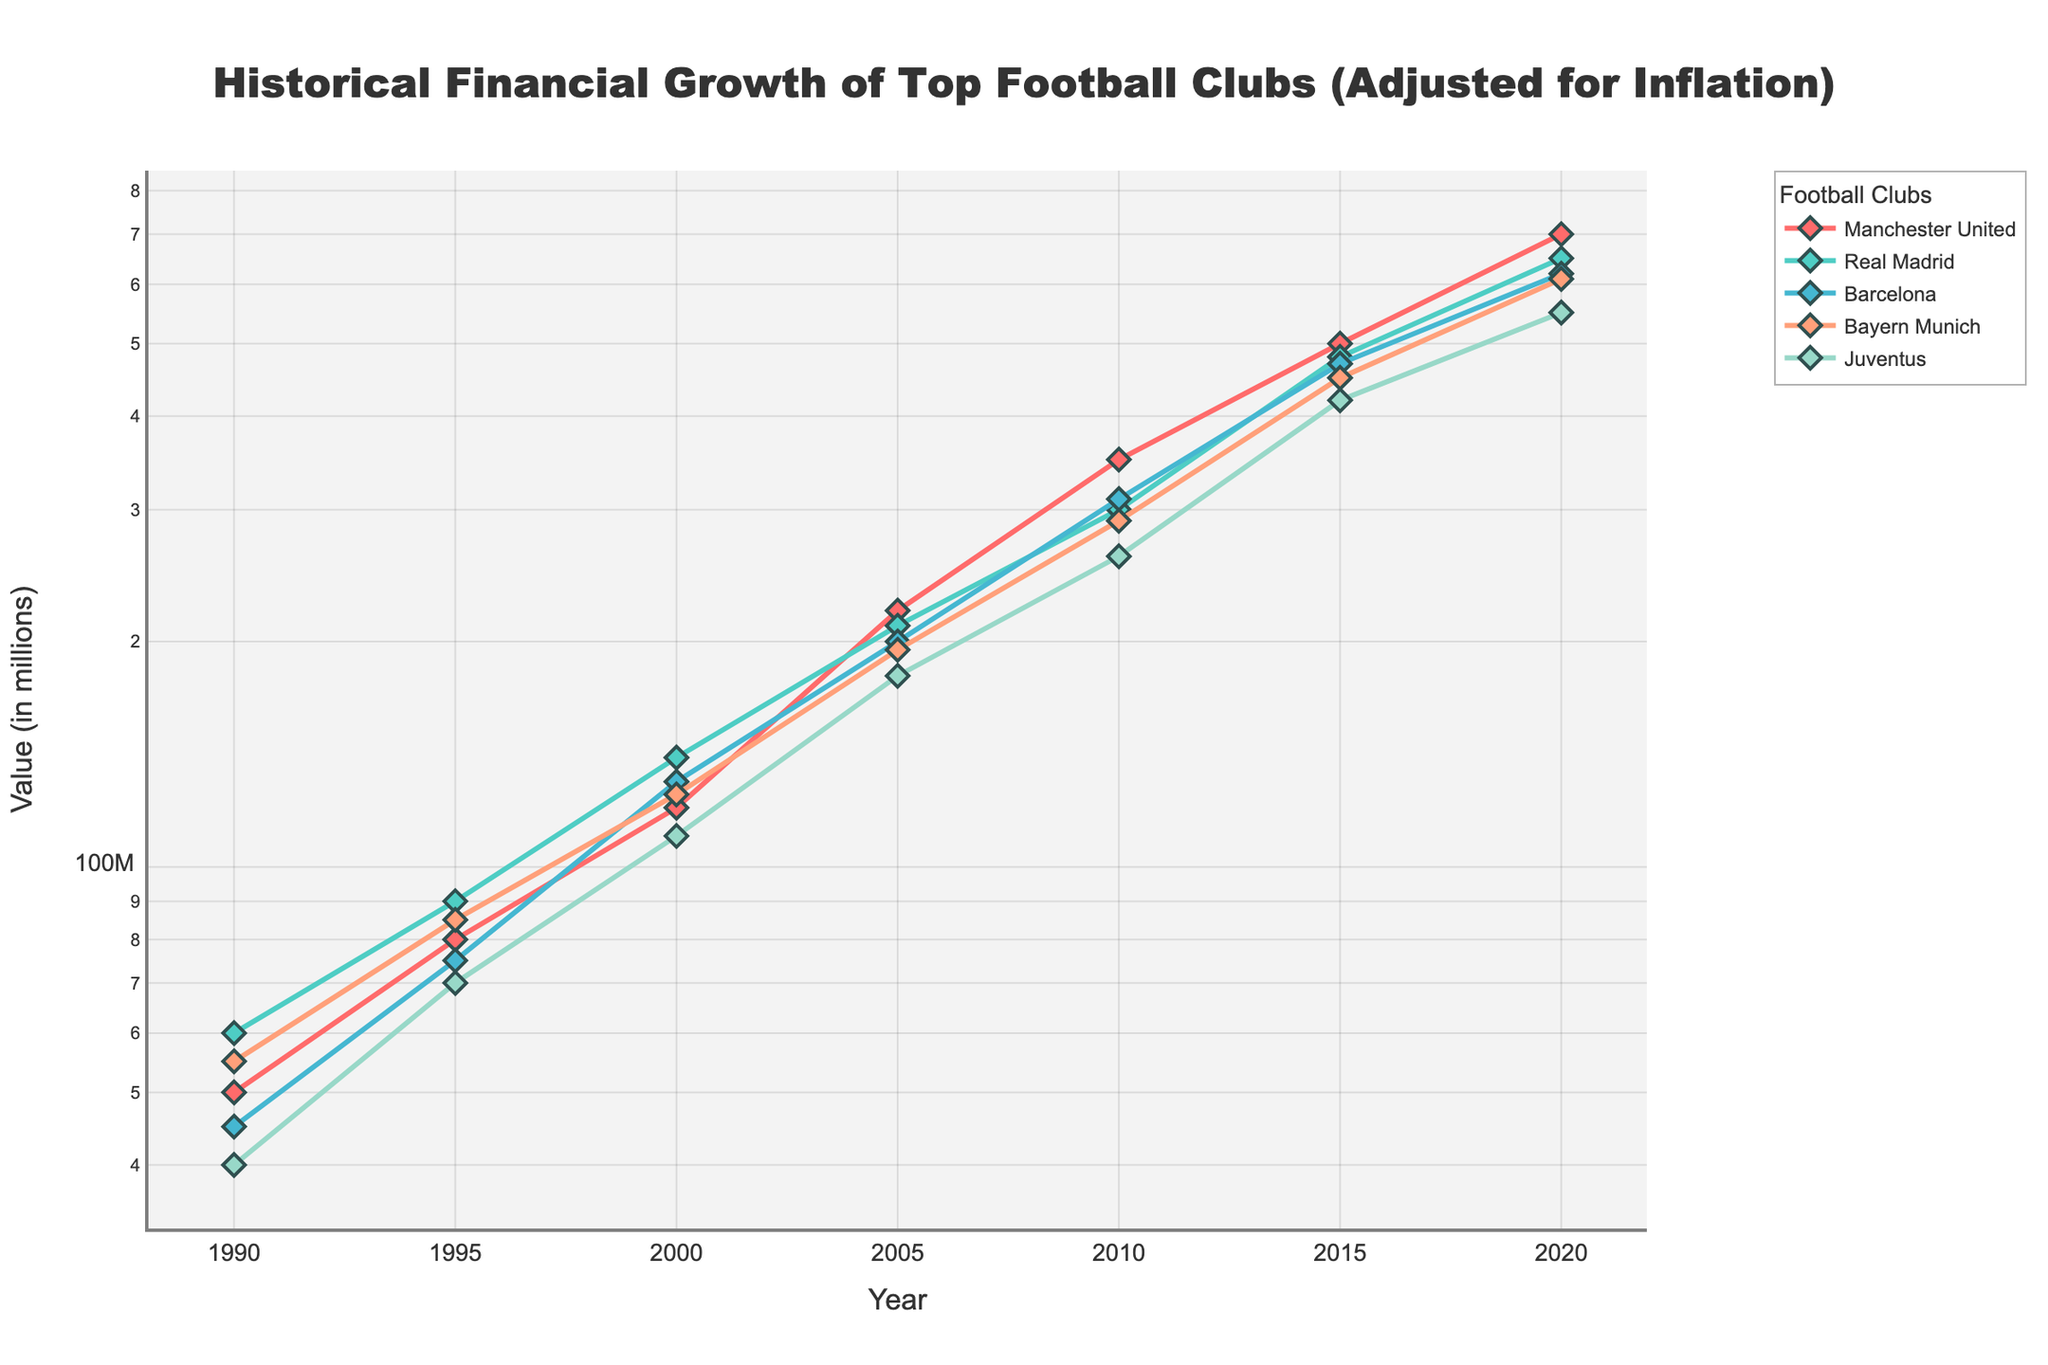What is the title of the plot? The title of the plot is displayed at the top and is centered in a larger font size. It reads: "Historical Financial Growth of Top Football Clubs (Adjusted for Inflation)"
Answer: Historical Financial Growth of Top Football Clubs (Adjusted for Inflation) What is the range of years shown on the x-axis? The x-axis displays the years from left to right. The range starts at 1990 and ends at 2020.
Answer: 1990 to 2020 Which club had the highest financial value in 2020? By looking at the endpoints on the right side of the plot for the year 2020, we observe that Manchester United's line is the highest on the plot compared to other clubs.
Answer: Manchester United Which two clubs had the closest financial values in 2010? Follow the points marked in 2010 for each club and compare their values. The financial values for Barcelona and Real Madrid are closest to each other since their markers are nearly at the same level.
Answer: Barcelona and Real Madrid How has the financial value of Juventus changed from 1990 to 2000? Trace the line for Juventus from 1990 to 2000. It starts at 40 million in 1990 and rises to 110 million by 2000. This shows a steady increase over the decade.
Answer: Increased Between 2005 and 2015, which club showed the most growth in financial value? Calculate the difference in financial value from 2005 to 2015 for all clubs: 
Manchester United: 500M - 220M = 280M
Real Madrid: 480M - 210M = 270M
Barcelona: 470M - 200M = 270M
Bayern Munich: 450M - 195M = 255M
Juventus: 420M - 180M = 240M
Manchester United has the highest growth.
Answer: Manchester United Which club had the smallest financial value in 1995? Trace the position of the markers for each club in the year 1995. Juventus' marker is the lowest at 70 million, compared to other clubs.
Answer: Juventus From 2000 to 2005, which club experienced a decrease in their financial value? By examining the lines between 2000 and 2005, it's clear that Real Madrid's value decreased from 140 million to 210 million before trending upward again towards 2010.
Answer: Real Madrid What is the general trend observed for financial values of these clubs from 1990 to 2020? Observe the overall direction of the lines for each club from 1990 to 2020. All lines show an upward trend, indicating an increase in financial value across all top clubs over this period.
Answer: Upward trend Which club had the fastest financial growth rate between 1990 and 2000? Determine the rate of change by comparing the difference in value over the time period: 
Manchester United: (120M - 50M) / 10 years = 7M/year 
Real Madrid: (140M - 60M) / 10 years = 8M/year 
Barcelona: (130M - 45M) / 10 years = 8.5M/year 
Bayern Munich: (125M - 55M) / 10 years = 7M/year 
Juventus: (110M - 40M) / 10 years = 7M/year 
Barcelona has the highest growth rate.
Answer: Barcelona 